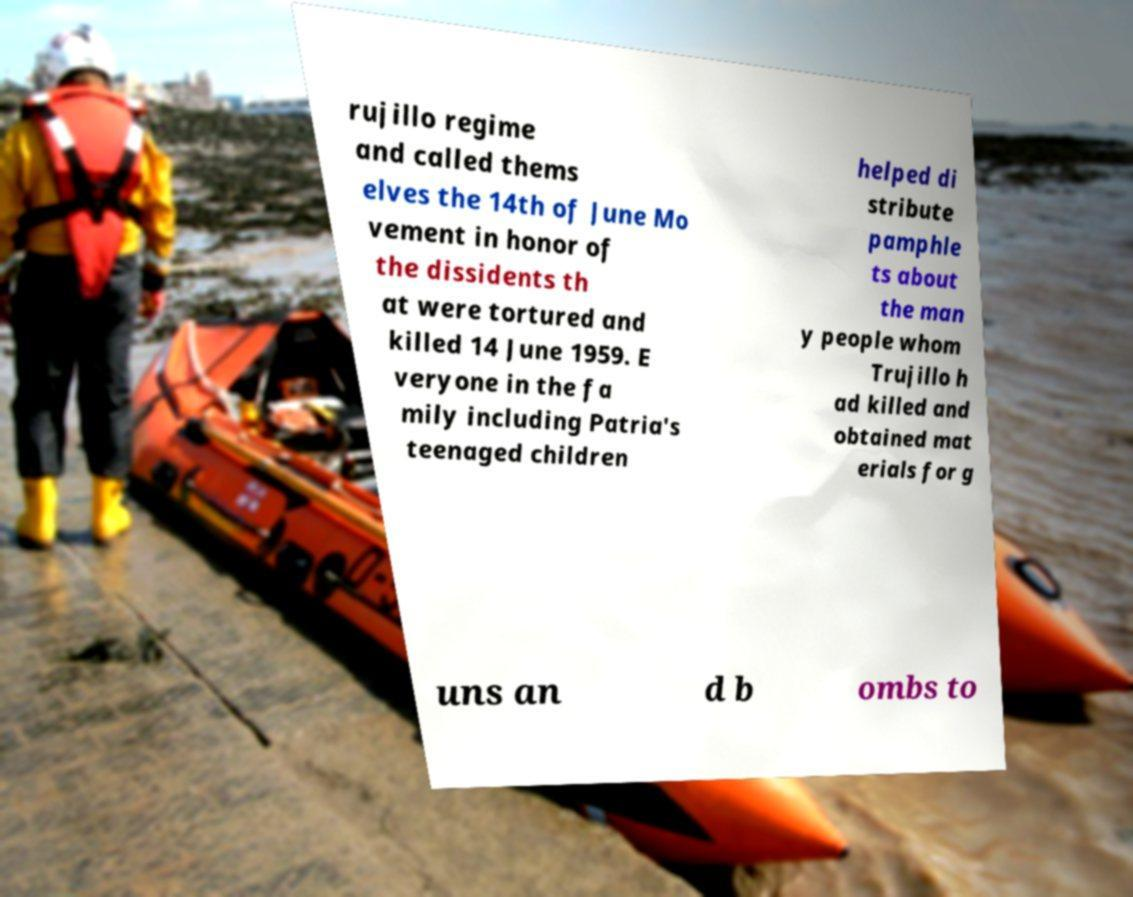Please identify and transcribe the text found in this image. rujillo regime and called thems elves the 14th of June Mo vement in honor of the dissidents th at were tortured and killed 14 June 1959. E veryone in the fa mily including Patria's teenaged children helped di stribute pamphle ts about the man y people whom Trujillo h ad killed and obtained mat erials for g uns an d b ombs to 